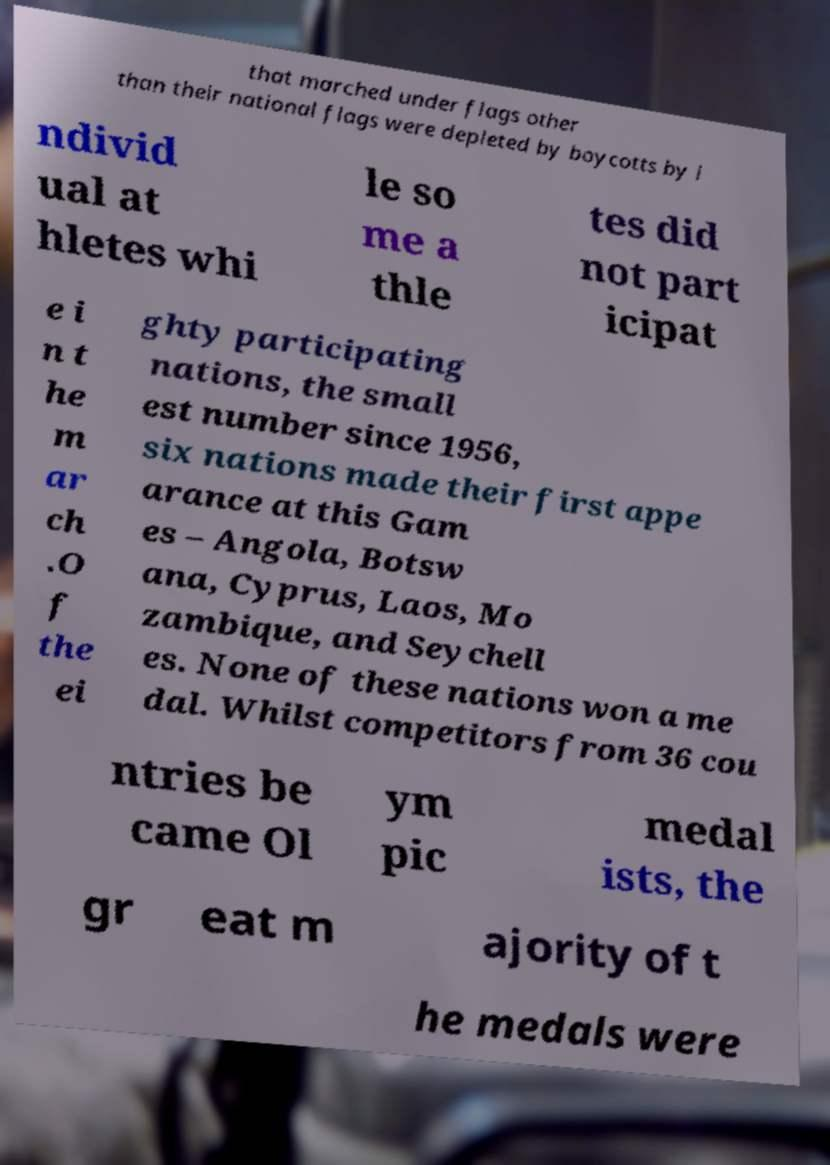Could you extract and type out the text from this image? that marched under flags other than their national flags were depleted by boycotts by i ndivid ual at hletes whi le so me a thle tes did not part icipat e i n t he m ar ch .O f the ei ghty participating nations, the small est number since 1956, six nations made their first appe arance at this Gam es – Angola, Botsw ana, Cyprus, Laos, Mo zambique, and Seychell es. None of these nations won a me dal. Whilst competitors from 36 cou ntries be came Ol ym pic medal ists, the gr eat m ajority of t he medals were 